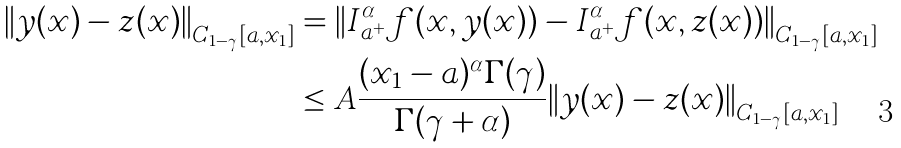<formula> <loc_0><loc_0><loc_500><loc_500>{ \| y ( x ) - z ( x ) \| } _ { C _ { 1 - \gamma } [ a , x _ { 1 } ] } & = { \| I _ { a ^ { + } } ^ { \alpha } f ( x , y ( x ) ) - I _ { a ^ { + } } ^ { \alpha } f ( x , z ( x ) ) \| } _ { C _ { 1 - \gamma } [ a , x _ { 1 } ] } \\ & \leq A \frac { ( x _ { 1 } - a ) ^ { \alpha } \Gamma ( \gamma ) } { \Gamma ( \gamma + \alpha ) } { \| y ( x ) - z ( x ) \| } _ { C _ { 1 - \gamma } [ a , x _ { 1 } ] }</formula> 